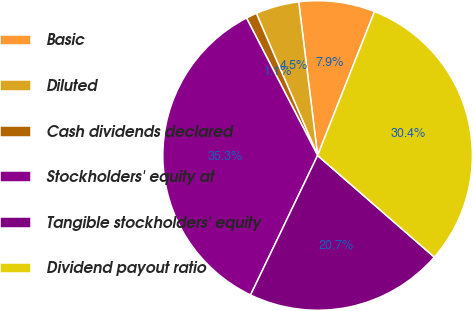Convert chart. <chart><loc_0><loc_0><loc_500><loc_500><pie_chart><fcel>Basic<fcel>Diluted<fcel>Cash dividends declared<fcel>Stockholders' equity at<fcel>Tangible stockholders' equity<fcel>Dividend payout ratio<nl><fcel>7.94%<fcel>4.53%<fcel>1.12%<fcel>35.27%<fcel>20.73%<fcel>30.41%<nl></chart> 